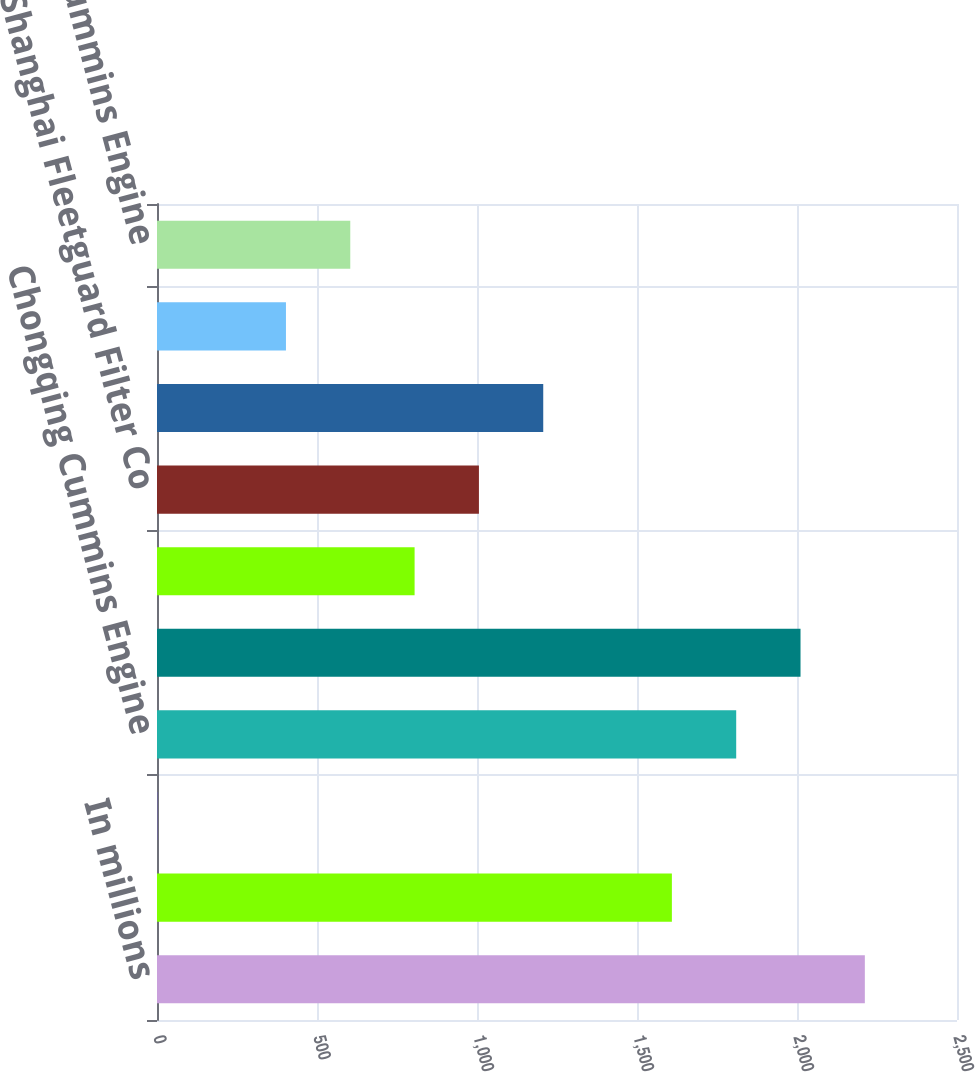<chart> <loc_0><loc_0><loc_500><loc_500><bar_chart><fcel>In millions<fcel>Komatsu Cummins Chile Ltda<fcel>All other distributors<fcel>Chongqing Cummins Engine<fcel>Dongfeng Cummins Engine<fcel>Cummins Westport Inc<fcel>Shanghai Fleetguard Filter Co<fcel>Tata Cummins Ltd<fcel>Valvoline Cummins Ltd<fcel>Beijing Foton Cummins Engine<nl><fcel>2212<fcel>1609<fcel>1<fcel>1810<fcel>2011<fcel>805<fcel>1006<fcel>1207<fcel>403<fcel>604<nl></chart> 